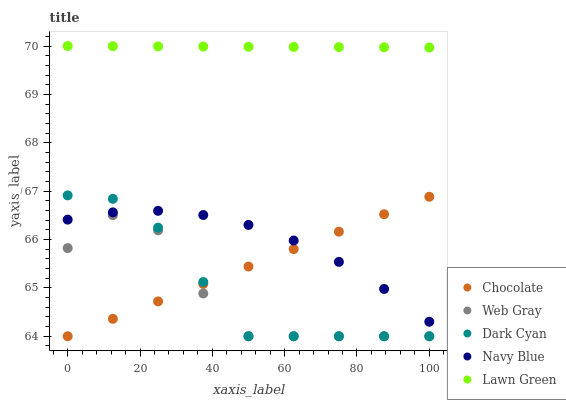Does Web Gray have the minimum area under the curve?
Answer yes or no. Yes. Does Lawn Green have the maximum area under the curve?
Answer yes or no. Yes. Does Navy Blue have the minimum area under the curve?
Answer yes or no. No. Does Navy Blue have the maximum area under the curve?
Answer yes or no. No. Is Chocolate the smoothest?
Answer yes or no. Yes. Is Web Gray the roughest?
Answer yes or no. Yes. Is Navy Blue the smoothest?
Answer yes or no. No. Is Navy Blue the roughest?
Answer yes or no. No. Does Dark Cyan have the lowest value?
Answer yes or no. Yes. Does Navy Blue have the lowest value?
Answer yes or no. No. Does Lawn Green have the highest value?
Answer yes or no. Yes. Does Navy Blue have the highest value?
Answer yes or no. No. Is Web Gray less than Lawn Green?
Answer yes or no. Yes. Is Navy Blue greater than Web Gray?
Answer yes or no. Yes. Does Chocolate intersect Navy Blue?
Answer yes or no. Yes. Is Chocolate less than Navy Blue?
Answer yes or no. No. Is Chocolate greater than Navy Blue?
Answer yes or no. No. Does Web Gray intersect Lawn Green?
Answer yes or no. No. 